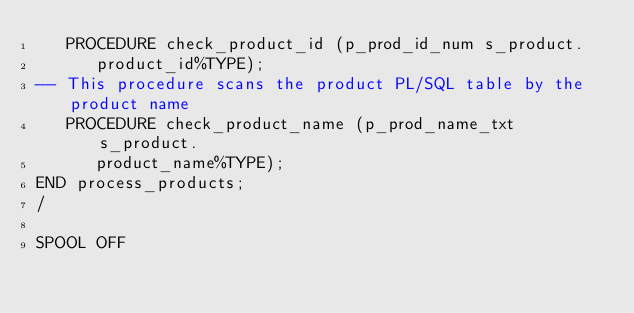<code> <loc_0><loc_0><loc_500><loc_500><_SQL_>   PROCEDURE check_product_id (p_prod_id_num s_product.
      product_id%TYPE);
-- This procedure scans the product PL/SQL table by the product name
   PROCEDURE check_product_name (p_prod_name_txt s_product.
      product_name%TYPE);
END process_products;
/

SPOOL OFF
</code> 